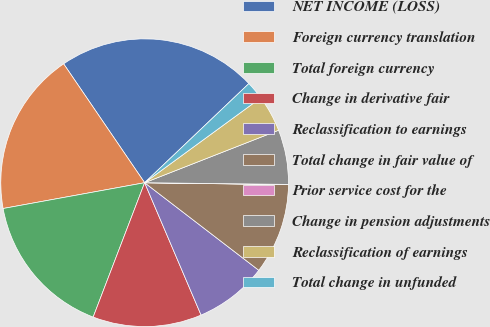Convert chart. <chart><loc_0><loc_0><loc_500><loc_500><pie_chart><fcel>NET INCOME (LOSS)<fcel>Foreign currency translation<fcel>Total foreign currency<fcel>Change in derivative fair<fcel>Reclassification to earnings<fcel>Total change in fair value of<fcel>Prior service cost for the<fcel>Change in pension adjustments<fcel>Reclassification of earnings<fcel>Total change in unfunded<nl><fcel>22.42%<fcel>18.35%<fcel>16.31%<fcel>12.24%<fcel>8.17%<fcel>10.2%<fcel>0.03%<fcel>6.13%<fcel>4.1%<fcel>2.06%<nl></chart> 